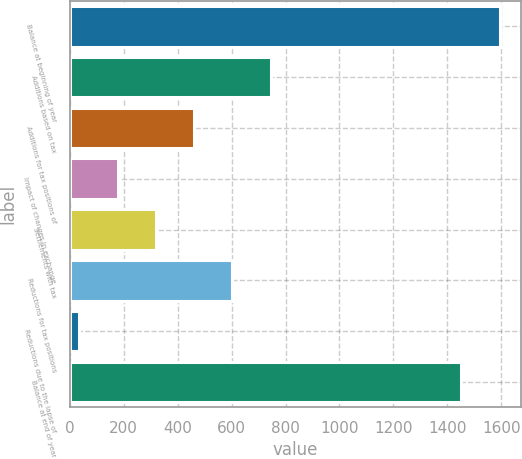Convert chart. <chart><loc_0><loc_0><loc_500><loc_500><bar_chart><fcel>Balance at beginning of year<fcel>Additions based on tax<fcel>Additions for tax positions of<fcel>Impact of changes in exchange<fcel>Settlements with tax<fcel>Reductions for tax positions<fcel>Reductions due to the lapse of<fcel>Balance at end of year<nl><fcel>1593.7<fcel>744.5<fcel>461.1<fcel>177.7<fcel>319.4<fcel>602.8<fcel>36<fcel>1452<nl></chart> 